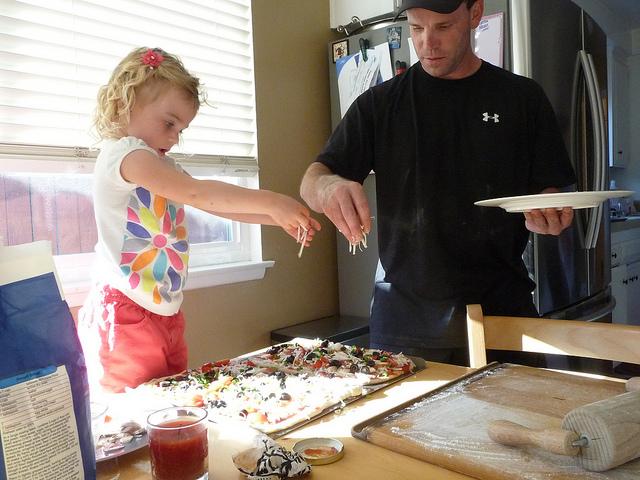Are they making homemade pizza?
Answer briefly. Yes. What brand of clothing is the man wearing?
Short answer required. Under armour. What is the man holding?
Answer briefly. Plate. 